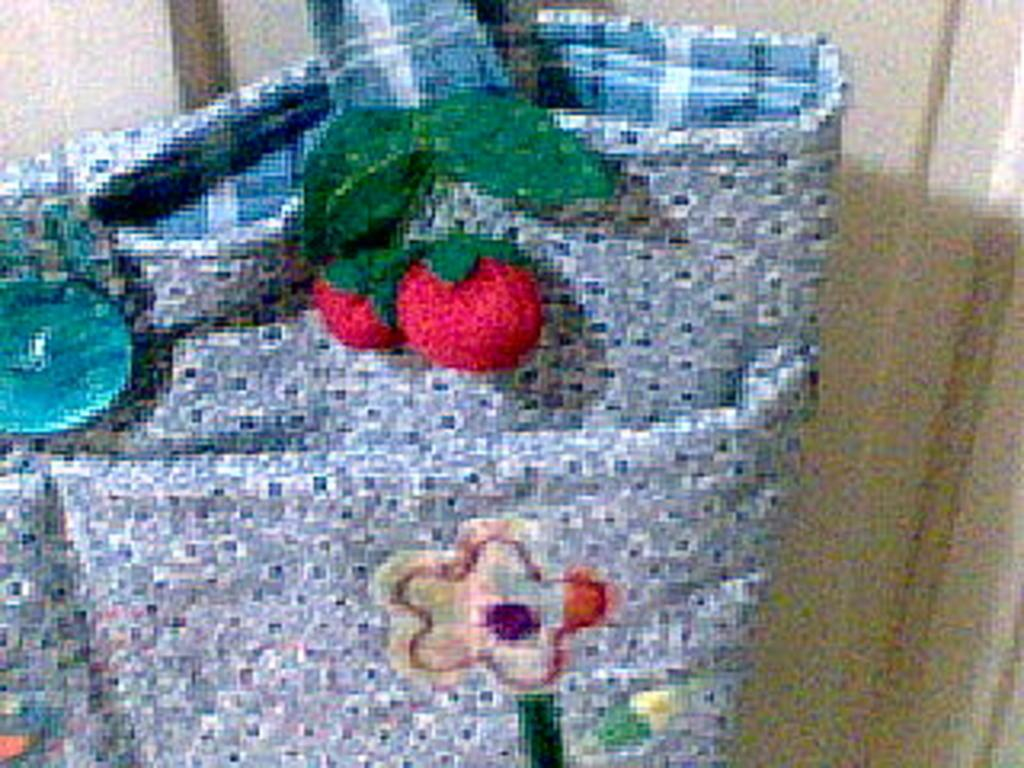What is the color of the bag in the image? The bag in the image is blue. What design is on the bag? The bag has red color cherries on it. Can you describe any other objects in the image? Yes, there is a flower in the image. Is there any other blue object in the image besides the bag? Yes, there is a blue color button in the image. Is there a faucet visible in the image? No, there is no faucet present in the image. Can you see any steam coming from the flower in the image? No, there is no steam present in the image. 